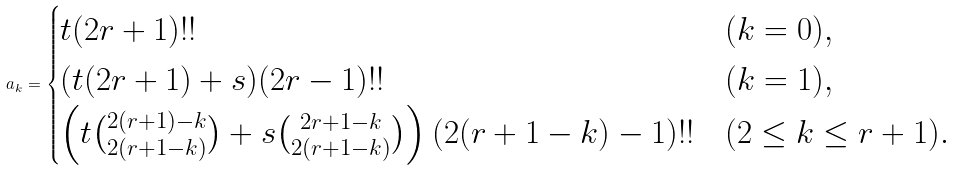<formula> <loc_0><loc_0><loc_500><loc_500>a _ { k } = \begin{cases} t ( 2 r + 1 ) ! ! & ( k = 0 ) , \\ ( t ( 2 r + 1 ) + s ) ( 2 r - 1 ) ! ! & ( k = 1 ) , \\ \left ( t \binom { 2 ( r + 1 ) - k } { 2 ( r + 1 - k ) } + s \binom { 2 r + 1 - k } { 2 ( r + 1 - k ) } \right ) ( 2 ( r + 1 - k ) - 1 ) ! ! & ( 2 \leq k \leq r + 1 ) . \end{cases}</formula> 